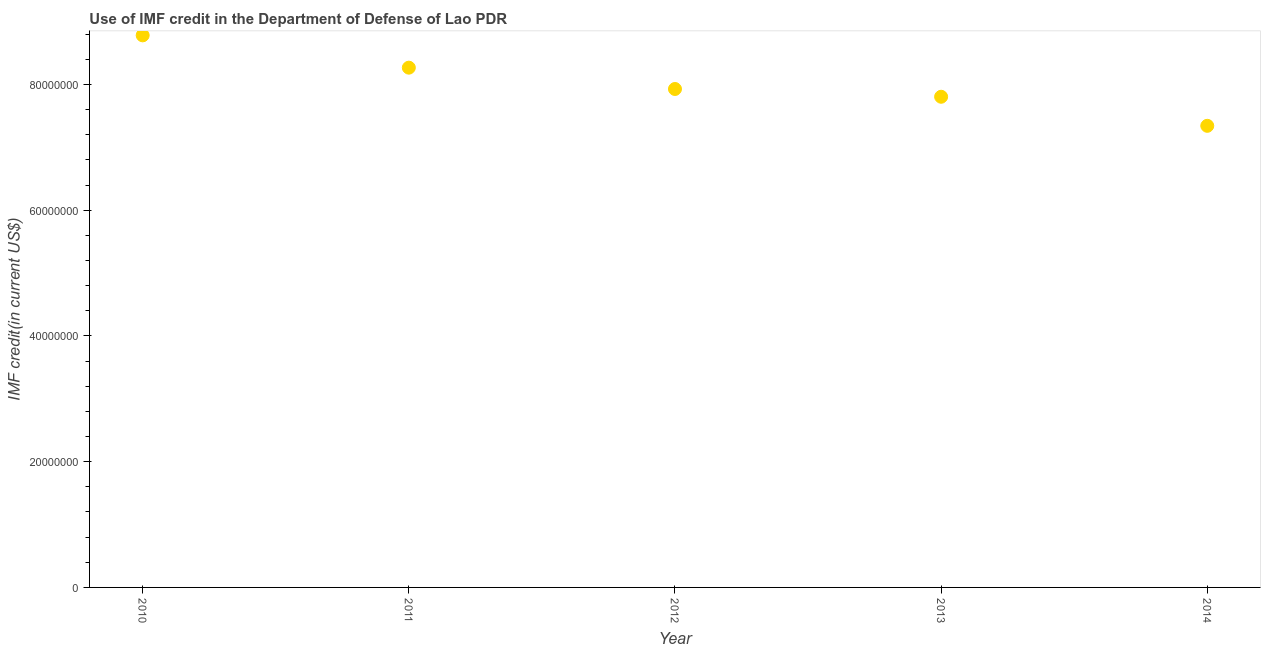What is the use of imf credit in dod in 2010?
Offer a terse response. 8.78e+07. Across all years, what is the maximum use of imf credit in dod?
Offer a very short reply. 8.78e+07. Across all years, what is the minimum use of imf credit in dod?
Ensure brevity in your answer.  7.34e+07. In which year was the use of imf credit in dod maximum?
Your response must be concise. 2010. In which year was the use of imf credit in dod minimum?
Your answer should be compact. 2014. What is the sum of the use of imf credit in dod?
Your answer should be compact. 4.01e+08. What is the difference between the use of imf credit in dod in 2011 and 2012?
Your answer should be compact. 3.39e+06. What is the average use of imf credit in dod per year?
Keep it short and to the point. 8.02e+07. What is the median use of imf credit in dod?
Offer a very short reply. 7.93e+07. In how many years, is the use of imf credit in dod greater than 84000000 US$?
Ensure brevity in your answer.  1. What is the ratio of the use of imf credit in dod in 2010 to that in 2012?
Offer a very short reply. 1.11. What is the difference between the highest and the second highest use of imf credit in dod?
Provide a short and direct response. 5.14e+06. What is the difference between the highest and the lowest use of imf credit in dod?
Provide a succinct answer. 1.44e+07. In how many years, is the use of imf credit in dod greater than the average use of imf credit in dod taken over all years?
Give a very brief answer. 2. How many years are there in the graph?
Keep it short and to the point. 5. Does the graph contain any zero values?
Keep it short and to the point. No. What is the title of the graph?
Provide a succinct answer. Use of IMF credit in the Department of Defense of Lao PDR. What is the label or title of the Y-axis?
Your answer should be very brief. IMF credit(in current US$). What is the IMF credit(in current US$) in 2010?
Keep it short and to the point. 8.78e+07. What is the IMF credit(in current US$) in 2011?
Offer a very short reply. 8.27e+07. What is the IMF credit(in current US$) in 2012?
Ensure brevity in your answer.  7.93e+07. What is the IMF credit(in current US$) in 2013?
Your response must be concise. 7.80e+07. What is the IMF credit(in current US$) in 2014?
Your answer should be very brief. 7.34e+07. What is the difference between the IMF credit(in current US$) in 2010 and 2011?
Offer a terse response. 5.14e+06. What is the difference between the IMF credit(in current US$) in 2010 and 2012?
Your answer should be compact. 8.53e+06. What is the difference between the IMF credit(in current US$) in 2010 and 2013?
Your response must be concise. 9.77e+06. What is the difference between the IMF credit(in current US$) in 2010 and 2014?
Offer a terse response. 1.44e+07. What is the difference between the IMF credit(in current US$) in 2011 and 2012?
Offer a very short reply. 3.39e+06. What is the difference between the IMF credit(in current US$) in 2011 and 2013?
Provide a short and direct response. 4.63e+06. What is the difference between the IMF credit(in current US$) in 2011 and 2014?
Keep it short and to the point. 9.25e+06. What is the difference between the IMF credit(in current US$) in 2012 and 2013?
Your response must be concise. 1.24e+06. What is the difference between the IMF credit(in current US$) in 2012 and 2014?
Your response must be concise. 5.86e+06. What is the difference between the IMF credit(in current US$) in 2013 and 2014?
Make the answer very short. 4.62e+06. What is the ratio of the IMF credit(in current US$) in 2010 to that in 2011?
Your response must be concise. 1.06. What is the ratio of the IMF credit(in current US$) in 2010 to that in 2012?
Your answer should be very brief. 1.11. What is the ratio of the IMF credit(in current US$) in 2010 to that in 2013?
Provide a succinct answer. 1.12. What is the ratio of the IMF credit(in current US$) in 2010 to that in 2014?
Offer a terse response. 1.2. What is the ratio of the IMF credit(in current US$) in 2011 to that in 2012?
Provide a short and direct response. 1.04. What is the ratio of the IMF credit(in current US$) in 2011 to that in 2013?
Provide a succinct answer. 1.06. What is the ratio of the IMF credit(in current US$) in 2011 to that in 2014?
Keep it short and to the point. 1.13. What is the ratio of the IMF credit(in current US$) in 2012 to that in 2013?
Your response must be concise. 1.02. What is the ratio of the IMF credit(in current US$) in 2013 to that in 2014?
Provide a short and direct response. 1.06. 